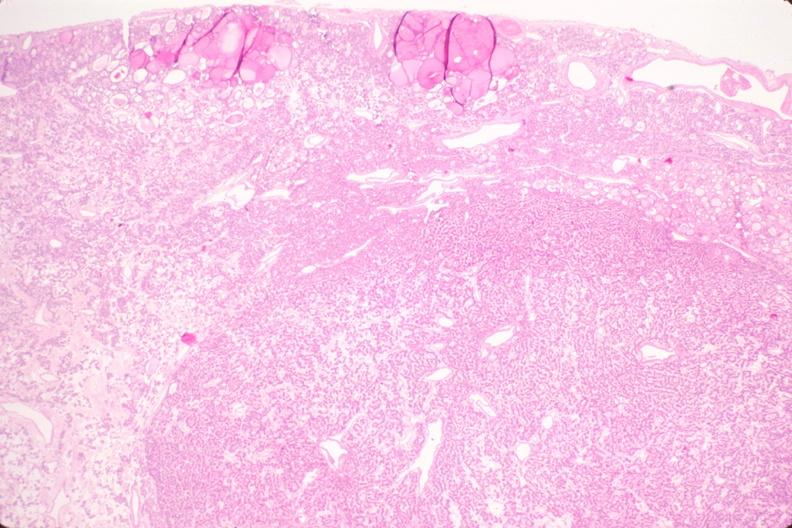does rocky mountain show thyroid, nodular hyperplasia?
Answer the question using a single word or phrase. No 